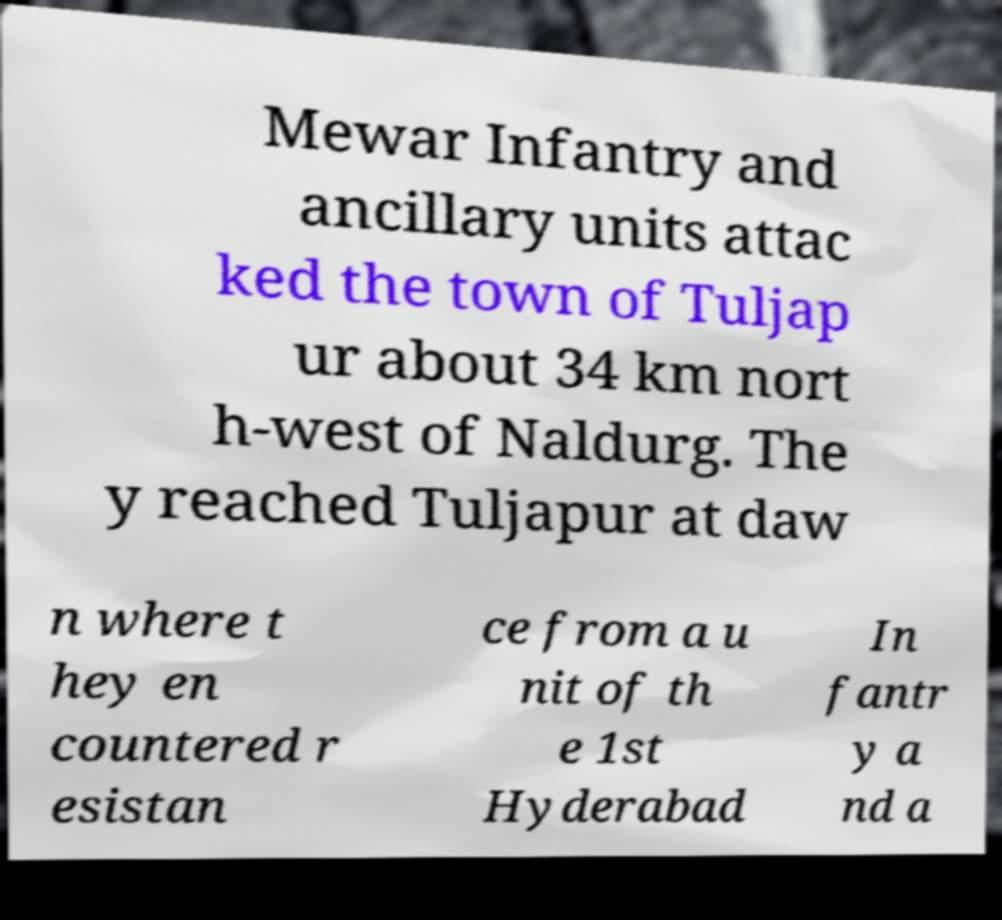For documentation purposes, I need the text within this image transcribed. Could you provide that? Mewar Infantry and ancillary units attac ked the town of Tuljap ur about 34 km nort h-west of Naldurg. The y reached Tuljapur at daw n where t hey en countered r esistan ce from a u nit of th e 1st Hyderabad In fantr y a nd a 